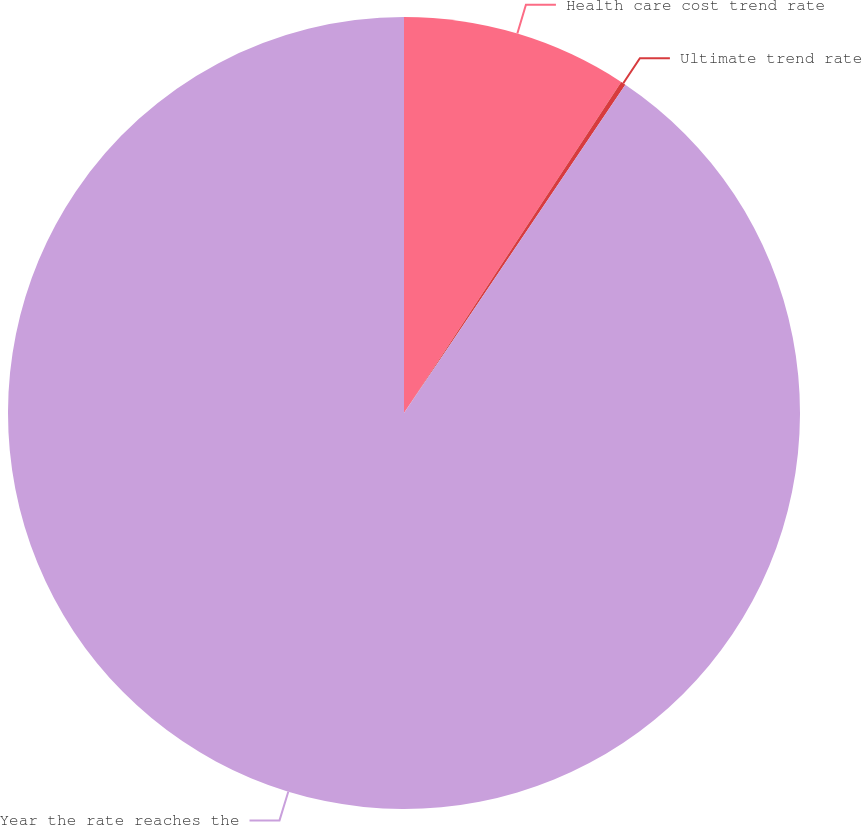<chart> <loc_0><loc_0><loc_500><loc_500><pie_chart><fcel>Health care cost trend rate<fcel>Ultimate trend rate<fcel>Year the rate reaches the<nl><fcel>9.24%<fcel>0.2%<fcel>90.56%<nl></chart> 